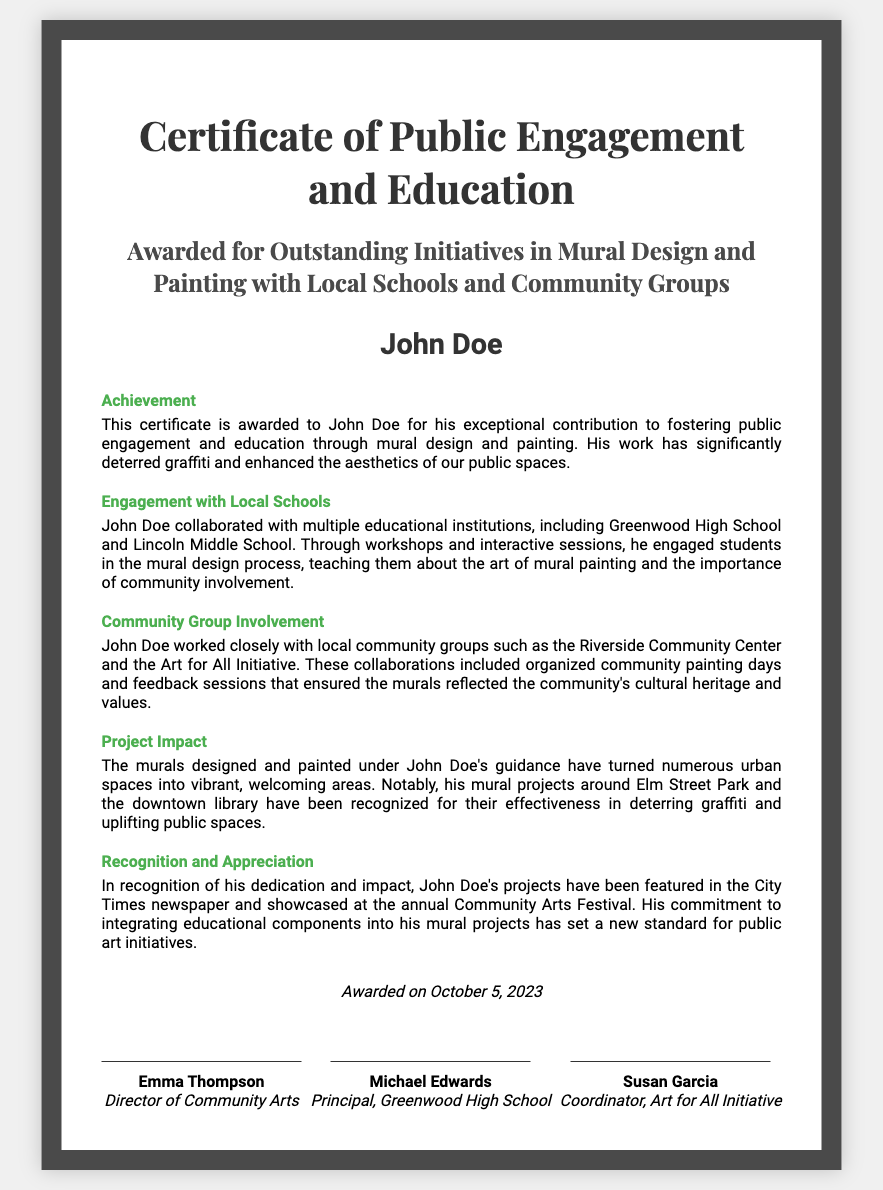What is the title of the certificate? The title is specified at the top of the document and identifies what the certificate is for.
Answer: Certificate of Public Engagement and Education Who is the recipient of the certificate? The recipient's name is prominently displayed in the document.
Answer: John Doe When was the certificate awarded? The date of the award is mentioned towards the end of the certificate.
Answer: October 5, 2023 Which local schools did John Doe collaborate with? The document lists the schools involved in the project during the engagement section.
Answer: Greenwood High School and Lincoln Middle School What was the primary goal of John Doe's initiatives? The overall purpose of the initiatives is highlighted in the achievement section of the certificate.
Answer: Deter graffiti and enhance aesthetics of public spaces Which community groups did John Doe work with? The certificate includes specific community groups that collaborated with the recipient.
Answer: Riverside Community Center and Art for All Initiative What notable recognition did John Doe's projects receive? The document highlights the media coverage and events where the projects were acknowledged.
Answer: City Times newspaper and annual Community Arts Festival What type of events did John Doe organize with local community groups? The section on community involvement details the nature of the events organized.
Answer: Community painting days and feedback sessions What are two locations where John Doe's murals are noted? The project impact section specifies locations where the murals have been created.
Answer: Elm Street Park and downtown library 